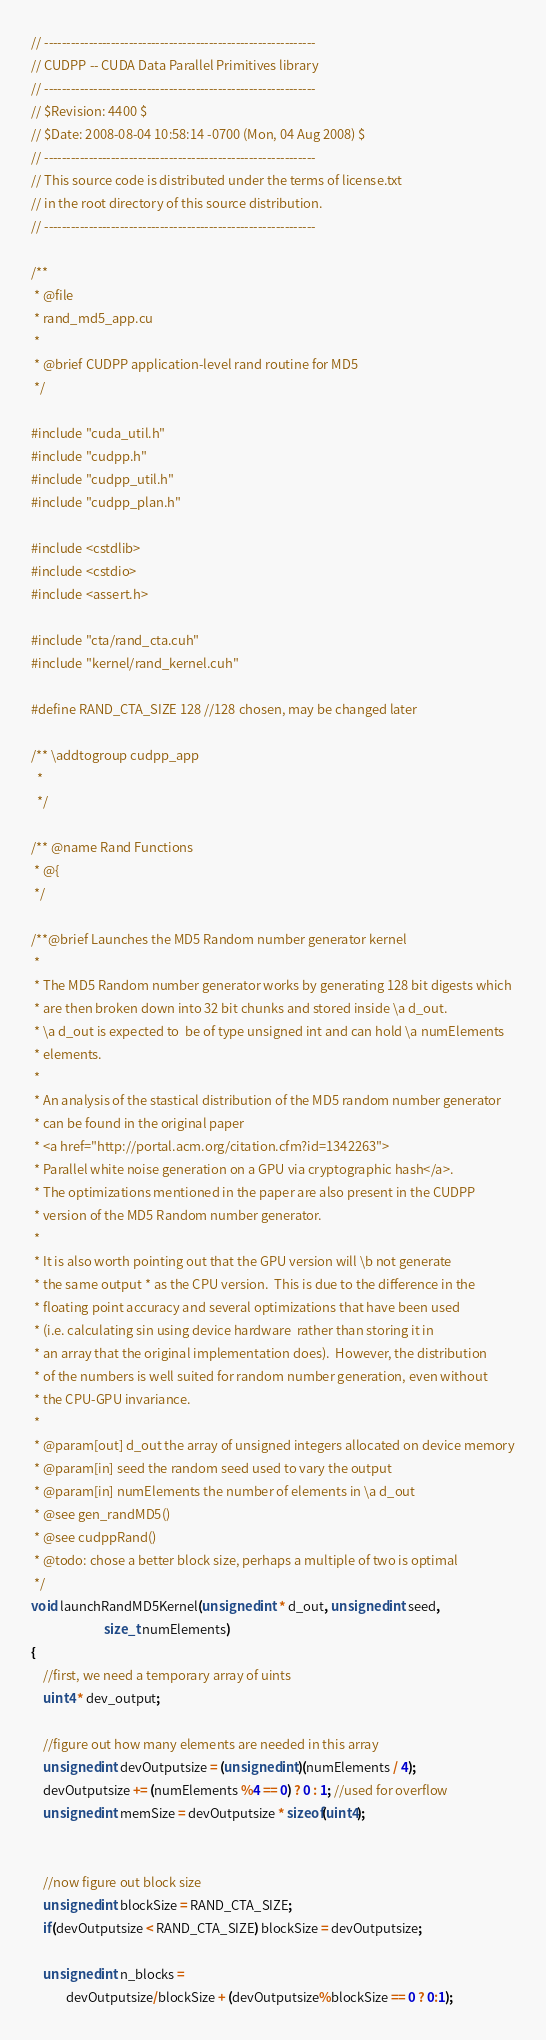Convert code to text. <code><loc_0><loc_0><loc_500><loc_500><_Cuda_>// -------------------------------------------------------------
// CUDPP -- CUDA Data Parallel Primitives library
// -------------------------------------------------------------
// $Revision: 4400 $
// $Date: 2008-08-04 10:58:14 -0700 (Mon, 04 Aug 2008) $
// ------------------------------------------------------------- 
// This source code is distributed under the terms of license.txt 
// in the root directory of this source distribution.
// ------------------------------------------------------------- 

/**
 * @file
 * rand_md5_app.cu
 *
 * @brief CUDPP application-level rand routine for MD5
 */

#include "cuda_util.h"
#include "cudpp.h"
#include "cudpp_util.h"
#include "cudpp_plan.h"

#include <cstdlib>
#include <cstdio>
#include <assert.h>

#include "cta/rand_cta.cuh"
#include "kernel/rand_kernel.cuh"

#define RAND_CTA_SIZE 128 //128 chosen, may be changed later

/** \addtogroup cudpp_app
  *
  */

/** @name Rand Functions
 * @{
 */

/**@brief Launches the MD5 Random number generator kernel
 *
 * The MD5 Random number generator works by generating 128 bit digests which 
 * are then broken down into 32 bit chunks and stored inside \a d_out.  
 * \a d_out is expected to  be of type unsigned int and can hold \a numElements 
 * elements.
 *
 * An analysis of the stastical distribution of the MD5 random number generator
 * can be found in the original paper 
 * <a href="http://portal.acm.org/citation.cfm?id=1342263">
 * Parallel white noise generation on a GPU via cryptographic hash</a>.
 * The optimizations mentioned in the paper are also present in the CUDPP
 * version of the MD5 Random number generator.
 *
 * It is also worth pointing out that the GPU version will \b not generate 
 * the same output * as the CPU version.  This is due to the difference in the 
 * floating point accuracy and several optimizations that have been used 
 * (i.e. calculating sin using device hardware  rather than storing it in 
 * an array that the original implementation does).  However, the distribution 
 * of the numbers is well suited for random number generation, even without
 * the CPU-GPU invariance.
 *
 * @param[out] d_out the array of unsigned integers allocated on device memory
 * @param[in] seed the random seed used to vary the output
 * @param[in] numElements the number of elements in \a d_out
 * @see gen_randMD5()
 * @see cudppRand()
 * @todo: chose a better block size, perhaps a multiple of two is optimal
 */
void launchRandMD5Kernel(unsigned int * d_out, unsigned int seed, 
                         size_t numElements)
{
    //first, we need a temporary array of uints
    uint4 * dev_output;

    //figure out how many elements are needed in this array
    unsigned int devOutputsize = (unsigned int)(numElements / 4);
    devOutputsize += (numElements %4 == 0) ? 0 : 1; //used for overflow
    unsigned int memSize = devOutputsize * sizeof(uint4);


    //now figure out block size
    unsigned int blockSize = RAND_CTA_SIZE;
    if(devOutputsize < RAND_CTA_SIZE) blockSize = devOutputsize;

    unsigned int n_blocks = 
            devOutputsize/blockSize + (devOutputsize%blockSize == 0 ? 0:1);  
</code> 